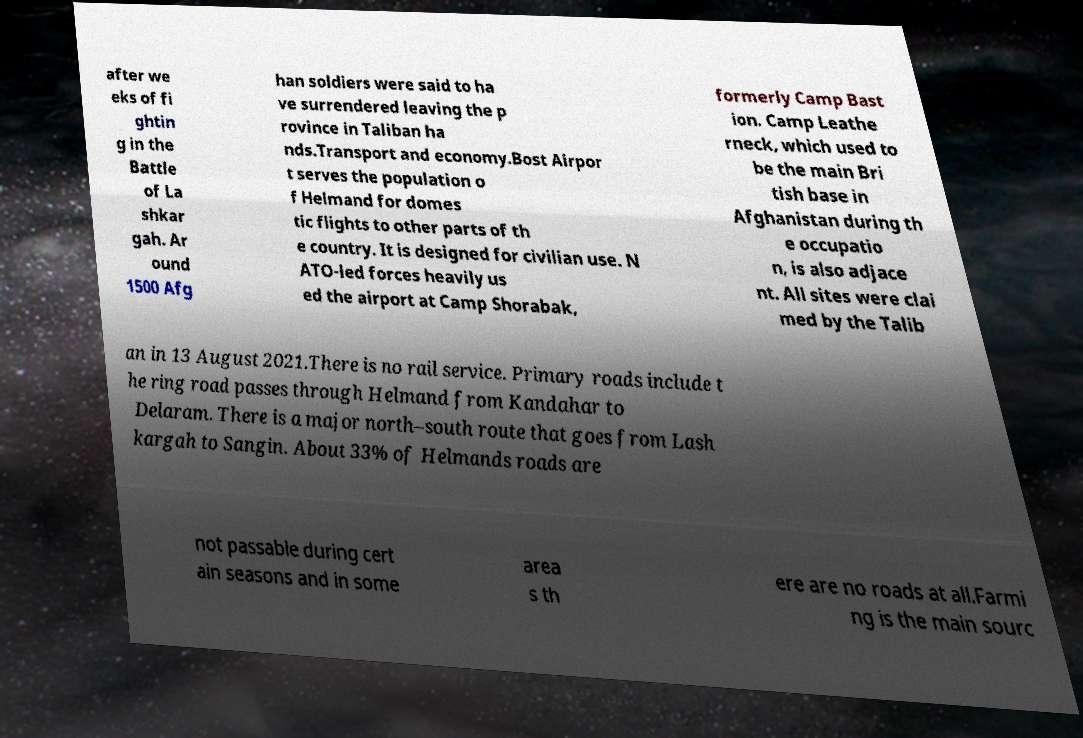Could you assist in decoding the text presented in this image and type it out clearly? after we eks of fi ghtin g in the Battle of La shkar gah. Ar ound 1500 Afg han soldiers were said to ha ve surrendered leaving the p rovince in Taliban ha nds.Transport and economy.Bost Airpor t serves the population o f Helmand for domes tic flights to other parts of th e country. It is designed for civilian use. N ATO-led forces heavily us ed the airport at Camp Shorabak, formerly Camp Bast ion. Camp Leathe rneck, which used to be the main Bri tish base in Afghanistan during th e occupatio n, is also adjace nt. All sites were clai med by the Talib an in 13 August 2021.There is no rail service. Primary roads include t he ring road passes through Helmand from Kandahar to Delaram. There is a major north–south route that goes from Lash kargah to Sangin. About 33% of Helmands roads are not passable during cert ain seasons and in some area s th ere are no roads at all.Farmi ng is the main sourc 